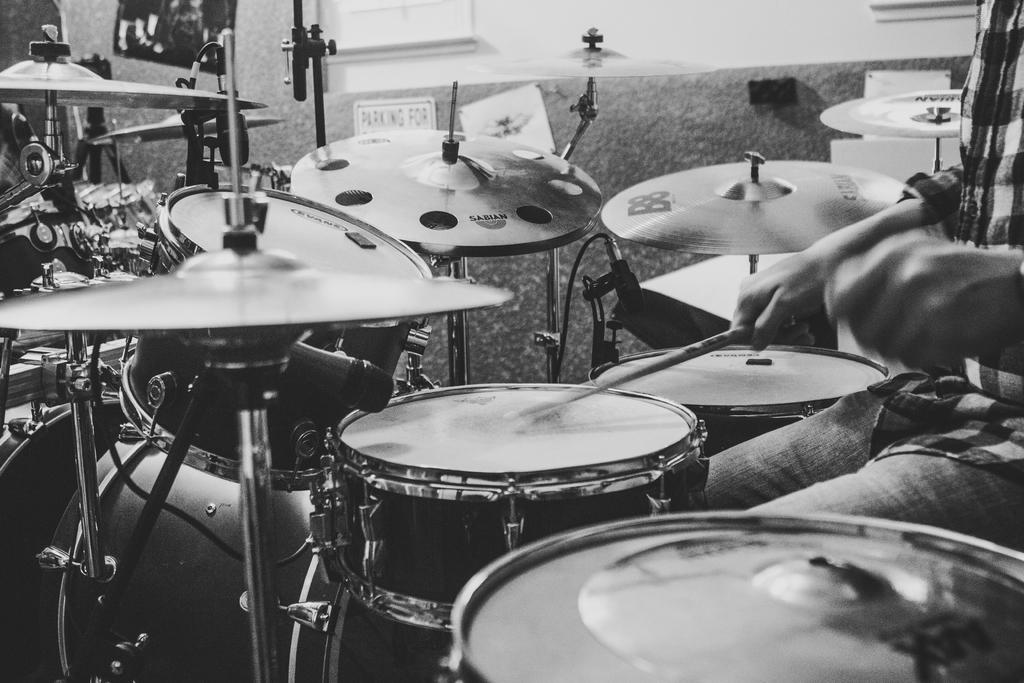What is the main object in the middle of the image? There are drums in the middle of the image. Can you describe the person on the right side of the image? There is a person on the right side of the image, but their appearance or actions are not specified. What color scheme is used in the image? The image is black and white. What type of wool is being used to make the school uniforms in the image? There is no school or wool present in the image; it features drums and a person. Can you compare the size of the drums to the person in the image? The size of the drums in relation to the person is not specified in the image. 